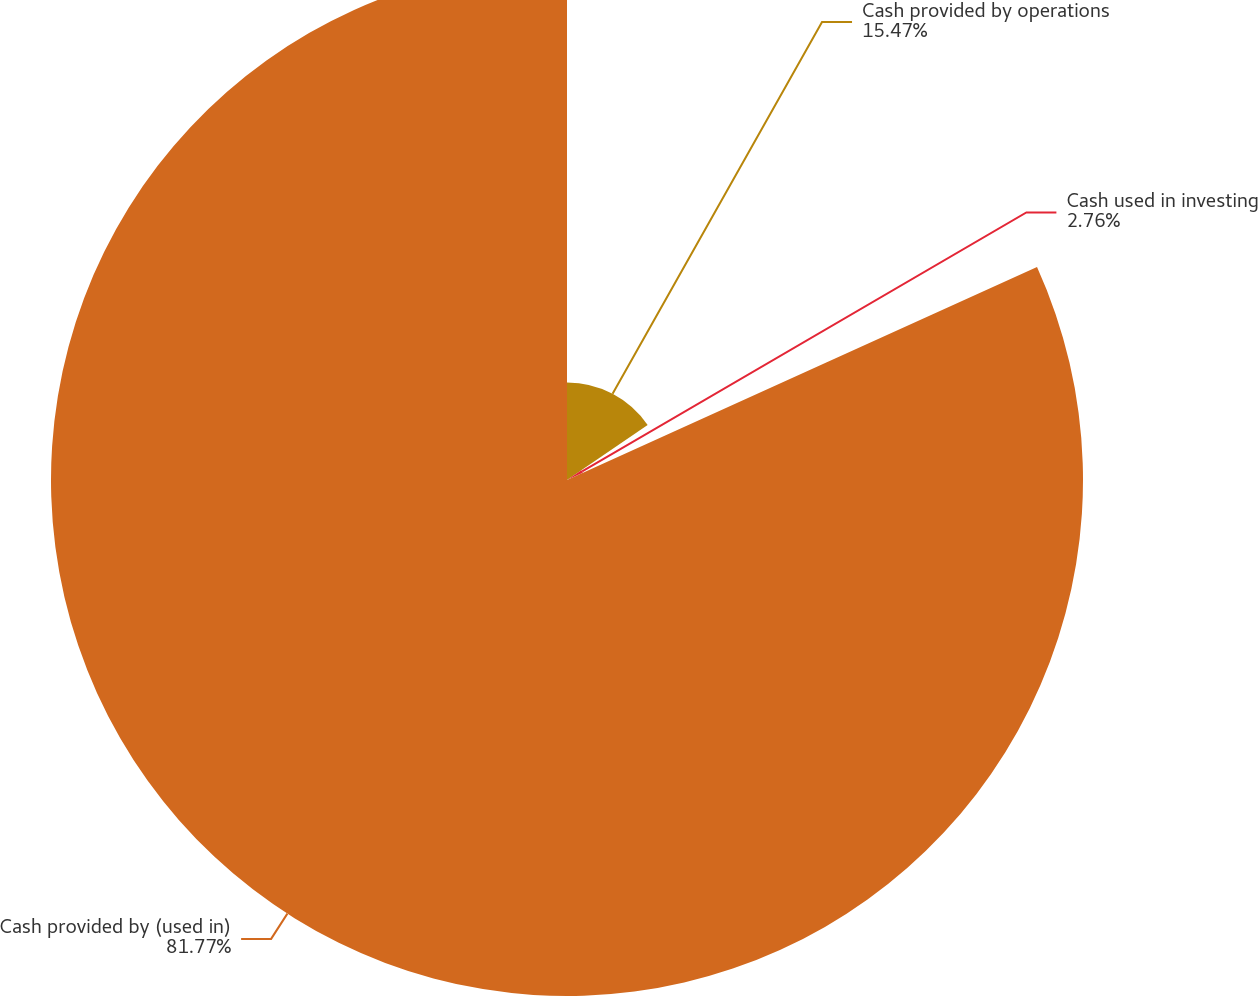Convert chart. <chart><loc_0><loc_0><loc_500><loc_500><pie_chart><fcel>Cash provided by operations<fcel>Cash used in investing<fcel>Cash provided by (used in)<nl><fcel>15.47%<fcel>2.76%<fcel>81.77%<nl></chart> 